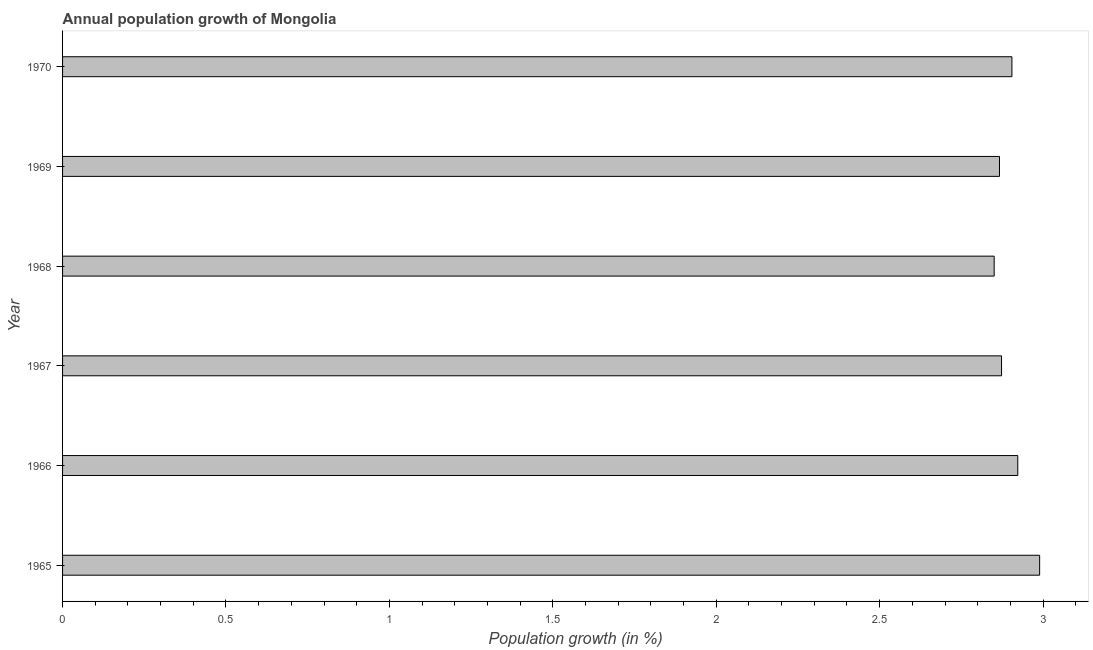Does the graph contain grids?
Offer a terse response. No. What is the title of the graph?
Provide a short and direct response. Annual population growth of Mongolia. What is the label or title of the X-axis?
Provide a short and direct response. Population growth (in %). What is the label or title of the Y-axis?
Your response must be concise. Year. What is the population growth in 1965?
Your answer should be compact. 2.99. Across all years, what is the maximum population growth?
Give a very brief answer. 2.99. Across all years, what is the minimum population growth?
Offer a very short reply. 2.85. In which year was the population growth maximum?
Offer a terse response. 1965. In which year was the population growth minimum?
Ensure brevity in your answer.  1968. What is the sum of the population growth?
Ensure brevity in your answer.  17.41. What is the difference between the population growth in 1967 and 1969?
Provide a short and direct response. 0.01. What is the average population growth per year?
Make the answer very short. 2.9. What is the median population growth?
Keep it short and to the point. 2.89. Do a majority of the years between 1967 and 1970 (inclusive) have population growth greater than 0.1 %?
Offer a very short reply. Yes. What is the ratio of the population growth in 1968 to that in 1970?
Provide a succinct answer. 0.98. Is the population growth in 1967 less than that in 1968?
Your response must be concise. No. What is the difference between the highest and the second highest population growth?
Your answer should be compact. 0.07. What is the difference between the highest and the lowest population growth?
Your answer should be compact. 0.14. How many bars are there?
Provide a short and direct response. 6. Are the values on the major ticks of X-axis written in scientific E-notation?
Offer a very short reply. No. What is the Population growth (in %) of 1965?
Provide a succinct answer. 2.99. What is the Population growth (in %) in 1966?
Offer a very short reply. 2.92. What is the Population growth (in %) in 1967?
Offer a very short reply. 2.87. What is the Population growth (in %) in 1968?
Your answer should be very brief. 2.85. What is the Population growth (in %) in 1969?
Provide a succinct answer. 2.87. What is the Population growth (in %) of 1970?
Make the answer very short. 2.9. What is the difference between the Population growth (in %) in 1965 and 1966?
Make the answer very short. 0.07. What is the difference between the Population growth (in %) in 1965 and 1967?
Offer a terse response. 0.12. What is the difference between the Population growth (in %) in 1965 and 1968?
Your response must be concise. 0.14. What is the difference between the Population growth (in %) in 1965 and 1969?
Keep it short and to the point. 0.12. What is the difference between the Population growth (in %) in 1965 and 1970?
Give a very brief answer. 0.08. What is the difference between the Population growth (in %) in 1966 and 1967?
Provide a succinct answer. 0.05. What is the difference between the Population growth (in %) in 1966 and 1968?
Provide a succinct answer. 0.07. What is the difference between the Population growth (in %) in 1966 and 1969?
Provide a short and direct response. 0.06. What is the difference between the Population growth (in %) in 1966 and 1970?
Keep it short and to the point. 0.02. What is the difference between the Population growth (in %) in 1967 and 1968?
Provide a succinct answer. 0.02. What is the difference between the Population growth (in %) in 1967 and 1969?
Keep it short and to the point. 0.01. What is the difference between the Population growth (in %) in 1967 and 1970?
Keep it short and to the point. -0.03. What is the difference between the Population growth (in %) in 1968 and 1969?
Your response must be concise. -0.02. What is the difference between the Population growth (in %) in 1968 and 1970?
Give a very brief answer. -0.05. What is the difference between the Population growth (in %) in 1969 and 1970?
Your response must be concise. -0.04. What is the ratio of the Population growth (in %) in 1965 to that in 1966?
Offer a very short reply. 1.02. What is the ratio of the Population growth (in %) in 1965 to that in 1967?
Your answer should be compact. 1.04. What is the ratio of the Population growth (in %) in 1965 to that in 1968?
Ensure brevity in your answer.  1.05. What is the ratio of the Population growth (in %) in 1965 to that in 1969?
Provide a short and direct response. 1.04. What is the ratio of the Population growth (in %) in 1966 to that in 1967?
Provide a short and direct response. 1.02. What is the ratio of the Population growth (in %) in 1966 to that in 1968?
Provide a short and direct response. 1.02. What is the ratio of the Population growth (in %) in 1966 to that in 1969?
Provide a succinct answer. 1.02. What is the ratio of the Population growth (in %) in 1967 to that in 1968?
Ensure brevity in your answer.  1.01. What is the ratio of the Population growth (in %) in 1967 to that in 1970?
Offer a very short reply. 0.99. What is the ratio of the Population growth (in %) in 1968 to that in 1970?
Your response must be concise. 0.98. What is the ratio of the Population growth (in %) in 1969 to that in 1970?
Ensure brevity in your answer.  0.99. 